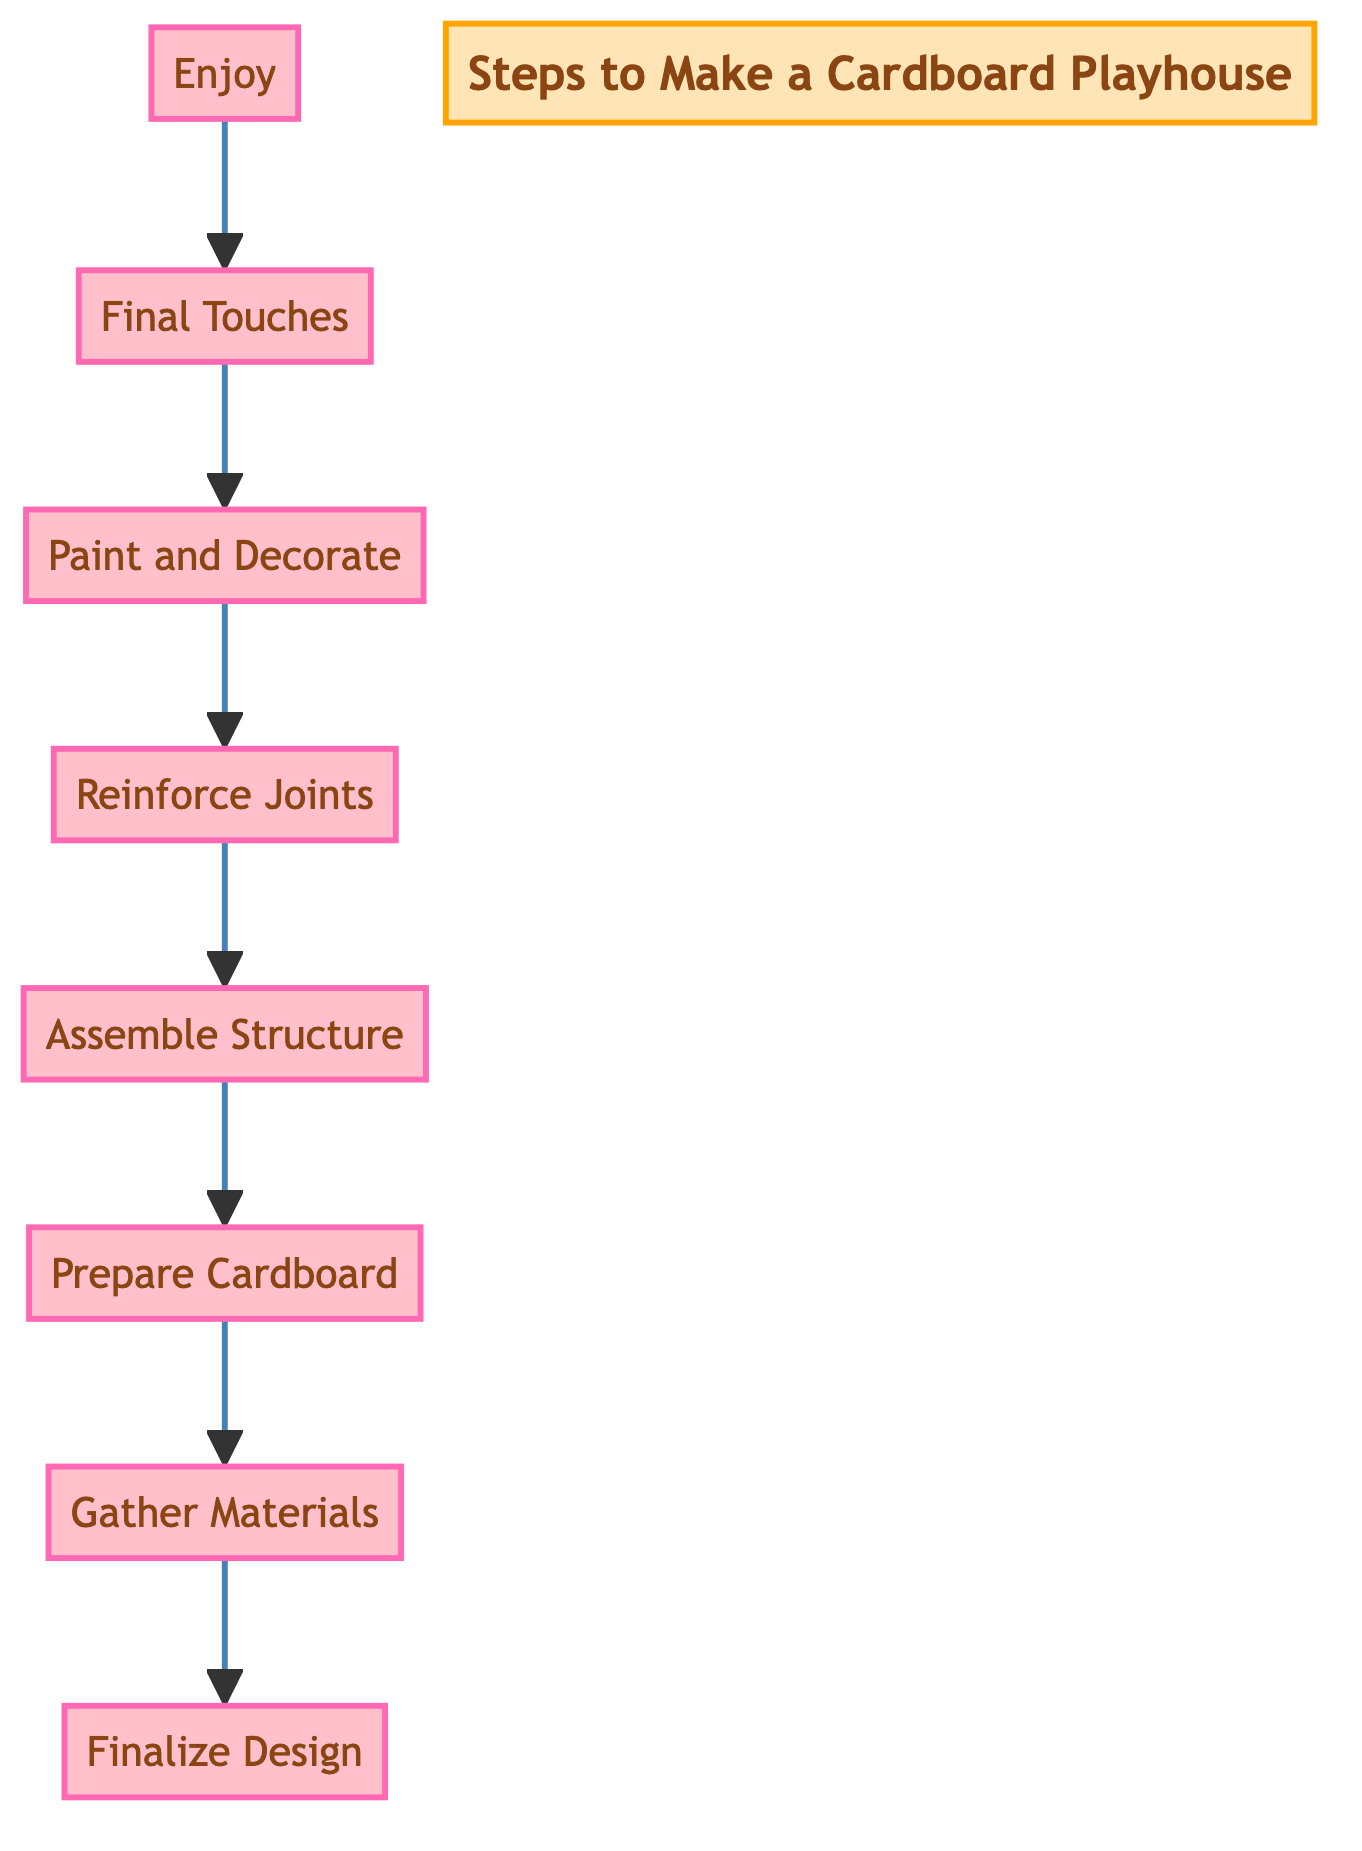What is the first step in making a cardboard playhouse? The diagram shows that the first step is located at the bottom and is labeled "Enjoy". However, when following the flow upwards, the final step before reaching the enjoyable phase is "Finalize Design", which is at the top of the flow.
Answer: Finalize Design How many steps are there in total? By counting the number of nodes in the flowchart, we find there are 8 clearly defined steps from "Finalize Design" to "Enjoy".
Answer: 8 What step comes after "Assemble Structure"? In the flowchart, "Assemble Structure" points to "Reinforce Joints" as the next step in the upwards flow. Therefore, the step that comes after it is "Reinforce Joints".
Answer: Reinforce Joints Which step involves painting and decorating? The diagram clearly shows "Paint and Decorate" as a distinct step that follows "Prepare Cardboard" and precedes "Final Touches". Therefore, this step is specifically designated for painting and decorating the playhouse.
Answer: Paint and Decorate What is the relationship between "Gather Materials" and "Prepare Cardboard"? In the flowchart, "Gather Materials" flows directly into "Prepare Cardboard" which indicates that gathering materials is a prerequisite for preparing the cardboard. Thus, the relationship is sequential, demonstrating that you must gather materials first before preparing the cardboard.
Answer: Sequential Which step is associated with adding extra stability? Looking at the flowchart, the step dedicated to adding extra stability through additional tape or glue is named "Reinforce Joints". It is specifically mentioned to boost the sturdiness of the playhouse's joints.
Answer: Reinforce Joints What is the endpoint of this flowchart? The end of the flowchart, or the last step at the bottom, is labeled "Enjoy", which indicates that once all prior steps are completed, the goal is to let the toddler play in the finished playhouse.
Answer: Enjoy What is the purpose of the "Final Touches" step? In the flowchart, "Final Touches" indicates a step where additional decorations such as curtains or a welcome sign can be added, enhancing the playhouse's appearance and functionality.
Answer: Additional decorations 